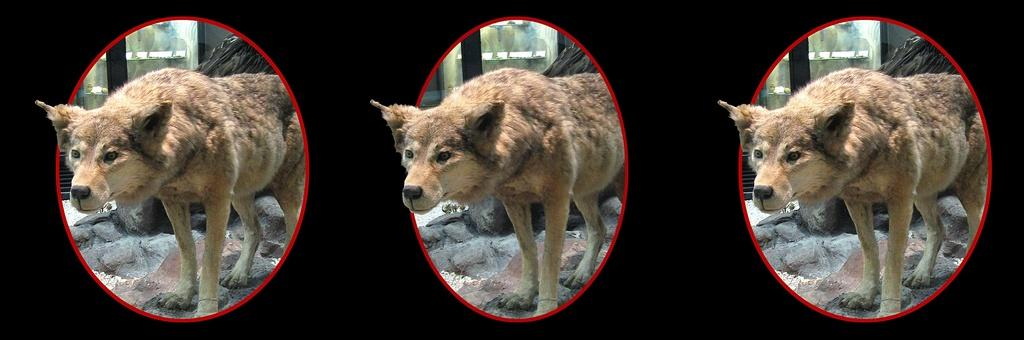How many dogs are present in the image? There are three dogs in the image. What is at the bottom of the image? There are stones at the bottom of the image. What can be seen in the background of the image? There are windows in the background of the image. What color is the background of the image? The background of the image is black. What type of eggnog is being served for dinner in the image? There is no eggnog or dinner present in the image; it features three dogs and stones at the bottom. 